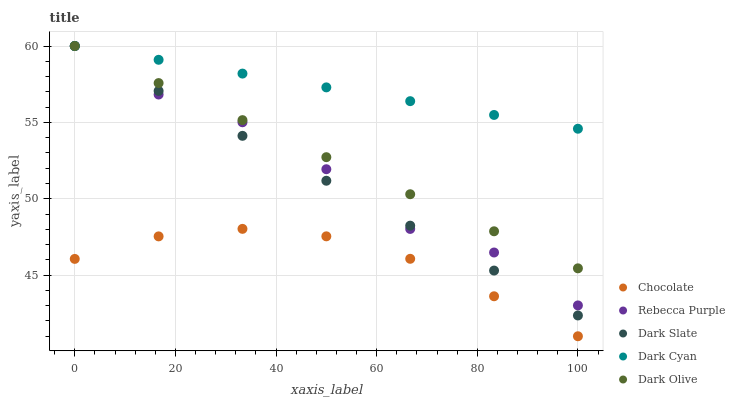Does Chocolate have the minimum area under the curve?
Answer yes or no. Yes. Does Dark Cyan have the maximum area under the curve?
Answer yes or no. Yes. Does Dark Slate have the minimum area under the curve?
Answer yes or no. No. Does Dark Slate have the maximum area under the curve?
Answer yes or no. No. Is Dark Slate the smoothest?
Answer yes or no. Yes. Is Rebecca Purple the roughest?
Answer yes or no. Yes. Is Dark Olive the smoothest?
Answer yes or no. No. Is Dark Olive the roughest?
Answer yes or no. No. Does Chocolate have the lowest value?
Answer yes or no. Yes. Does Dark Slate have the lowest value?
Answer yes or no. No. Does Rebecca Purple have the highest value?
Answer yes or no. Yes. Does Chocolate have the highest value?
Answer yes or no. No. Is Chocolate less than Dark Cyan?
Answer yes or no. Yes. Is Rebecca Purple greater than Chocolate?
Answer yes or no. Yes. Does Dark Cyan intersect Dark Olive?
Answer yes or no. Yes. Is Dark Cyan less than Dark Olive?
Answer yes or no. No. Is Dark Cyan greater than Dark Olive?
Answer yes or no. No. Does Chocolate intersect Dark Cyan?
Answer yes or no. No. 